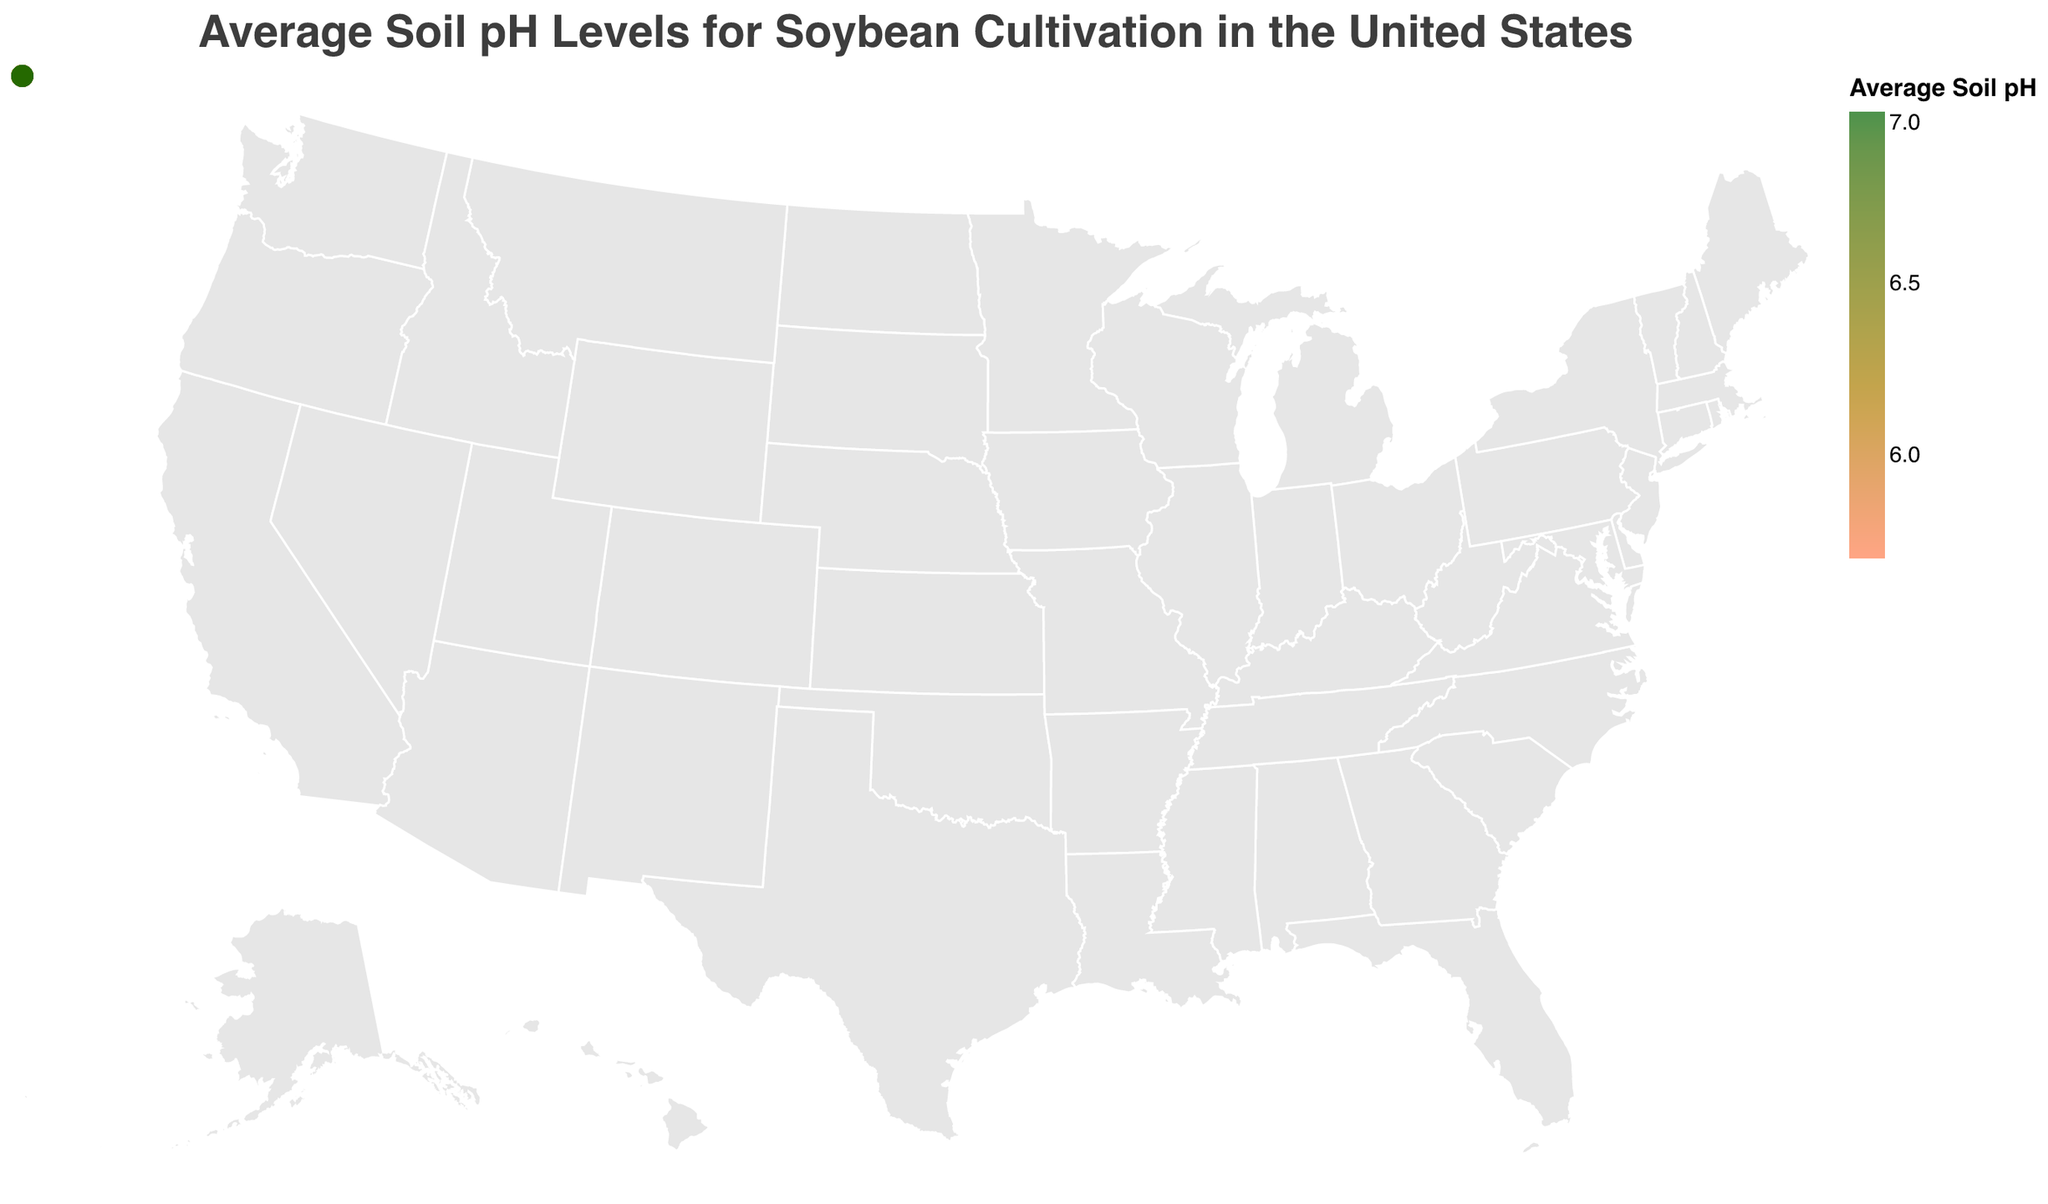What is the average soil pH level in Iowa? According to the figure, Iowa has an average soil pH level of 6.8.
Answer: 6.8 Which state has the highest average soil pH level for soybean cultivation? By observing the figure, South Dakota shows the highest average soil pH level at 7.0.
Answer: South Dakota Compare the average soil pH levels between Minnesota and Missouri. Which one is higher? Minnesota has an average soil pH of 6.3, while Missouri has 6.4. Therefore, Missouri's average soil pH level is higher.
Answer: Missouri What is the range of average soil pH levels represented in the figure? The lowest average soil pH level is in Virginia at 5.7, and the highest is in South Dakota at 7.0, giving a range of 7.0 - 5.7 = 1.3.
Answer: 1.3 How many states have an average soil pH level of 6.5 or higher? States with an average soil pH level of 6.5 or higher: Iowa (6.8), Illinois (6.5), Indiana (6.7), Ohio (6.6), Michigan (6.6), Wisconsin (6.5), South Dakota (7.0), Nebraska (6.9). There are 8 states in total.
Answer: 8 Which regions have at least one state with an average soil pH level below 6.0? The regions with states having an average soil pH below 6.0 are:
- South: Louisiana (5.9)
- Southeast: North Carolina (5.8), Virginia (5.7)
Answer: South, Southeast What's the average soil pH level in the Midwest region? The Midwest states and their average soil pH levels are: Iowa (6.8), Illinois (6.5), Minnesota (6.3), Indiana (6.7), Ohio (6.6), Missouri (6.4). Sum these for a total of 38.3, divided by 6 states, the average is 6.38.
Answer: 6.38 Are there more states with an average soil pH level below or above 6.2? States with a soil pH below 6.2: Arkansas, Mississippi, Louisiana, North Carolina, Tennessee, Virginia, Maryland. Total = 7 states. States above 6.2: Iowa, Illinois, Minnesota, Indiana, Ohio, Missouri, Delaware, Pennsylvania, Michigan, Wisconsin, South Dakota, Nebraska. Total = 12 states. There are more states with a soil pH level above 6.2.
Answer: Above Which state in the Southeast region has the lowest average soil pH level? By observing the figure, Virginia in the Southeast region has the lowest average soil pH level at 5.7.
Answer: Virginia Is there a noticeable geographical trend in soil pH levels across the United States? The figure indicates that southern and southeastern states tend to have lower soil pH levels, while midwestern and northern states have higher soil pH levels.
Answer: Yes 